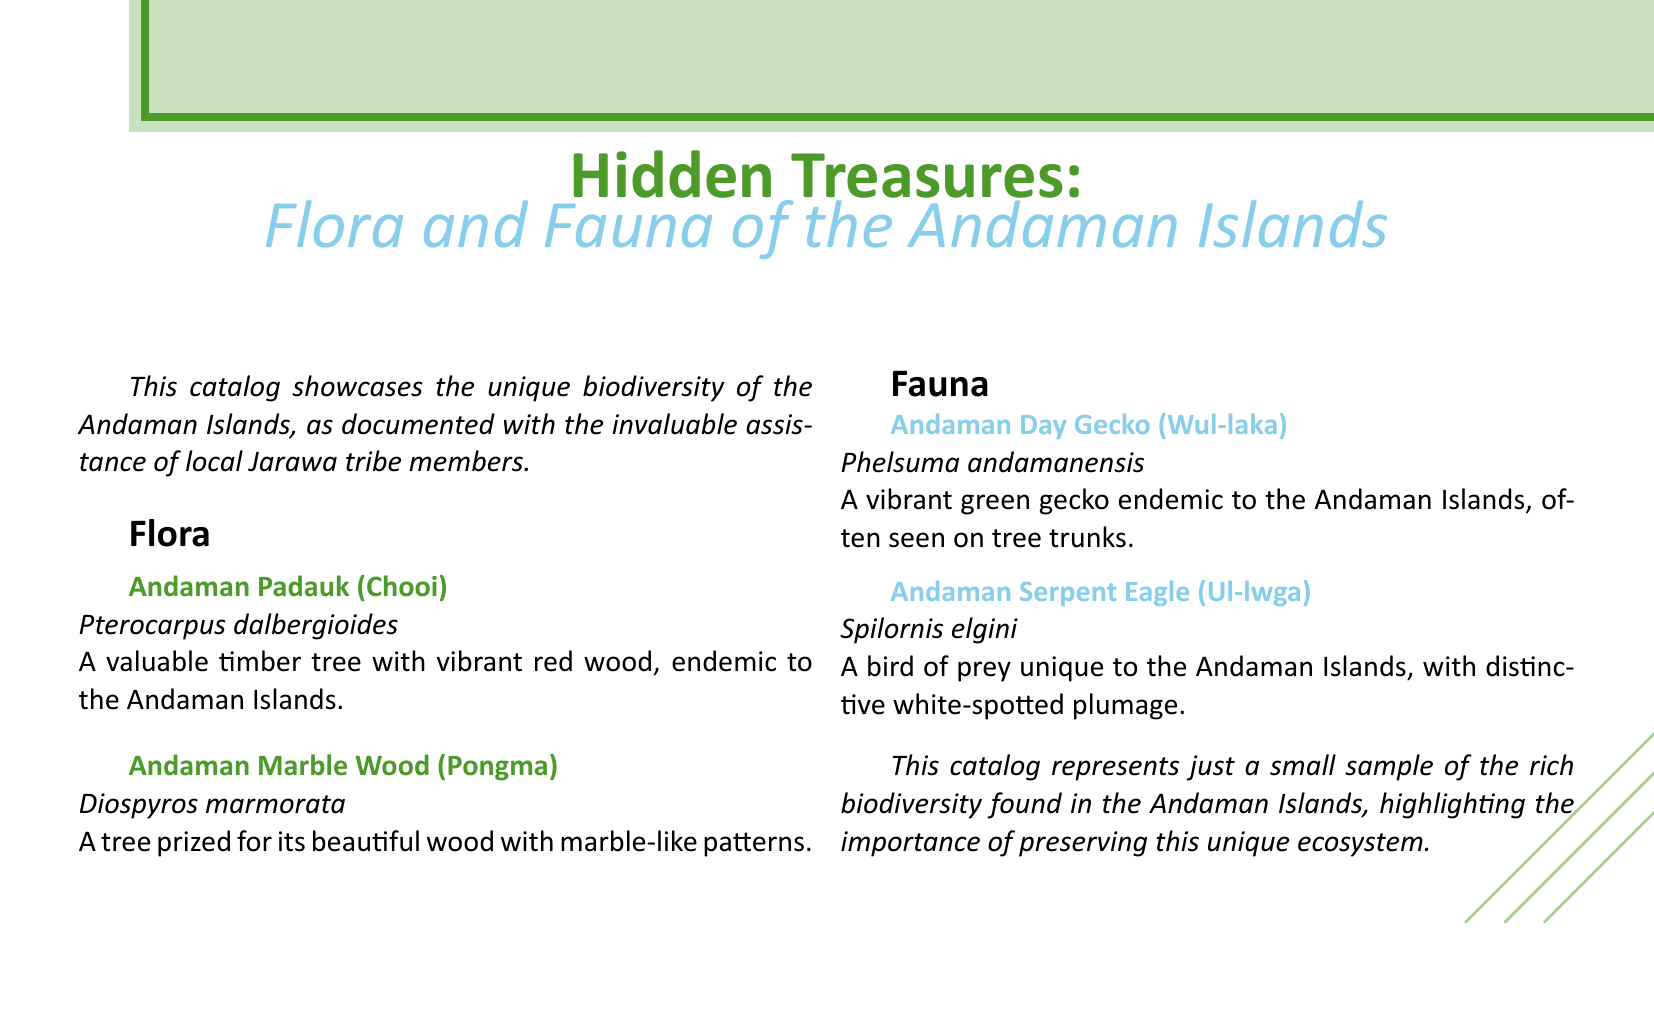What is the title of the catalog? The title indicates what the catalog is about and its theme, displayed prominently at the top of the document.
Answer: Hidden Treasures: Flora and Fauna of the Andaman Islands Who assisted in documenting the biodiversity? The catalog mentions a specific group that played a vital role in providing knowledge about the local flora and fauna.
Answer: local Jarawa tribe members What is the scientific name of the Andaman Padauk? This is a specific piece of information provided in the catalog regarding one of the plants featured.
Answer: Pterocarpus dalbergioides Which color is the Andaman Day Gecko? The catalog includes descriptions of the fauna, which often include their physical appearances.
Answer: vibrant green What is a characteristic feature of the Andaman Serpent Eagle? This question draws on the unique traits of the bird described in the fauna section.
Answer: white-spotted plumage How many flora entries are listed? This question prompts a count of the distinct flora entries within the document.
Answer: 2 What does the catalog emphasize about the ecosystem? The concluding statement in the document reflects on the importance of the presented information.
Answer: preserving this unique ecosystem What type of document is this? This question pertains to the specific nature of the compiled information as described in the opening.
Answer: catalog 